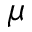Convert formula to latex. <formula><loc_0><loc_0><loc_500><loc_500>\mu</formula> 